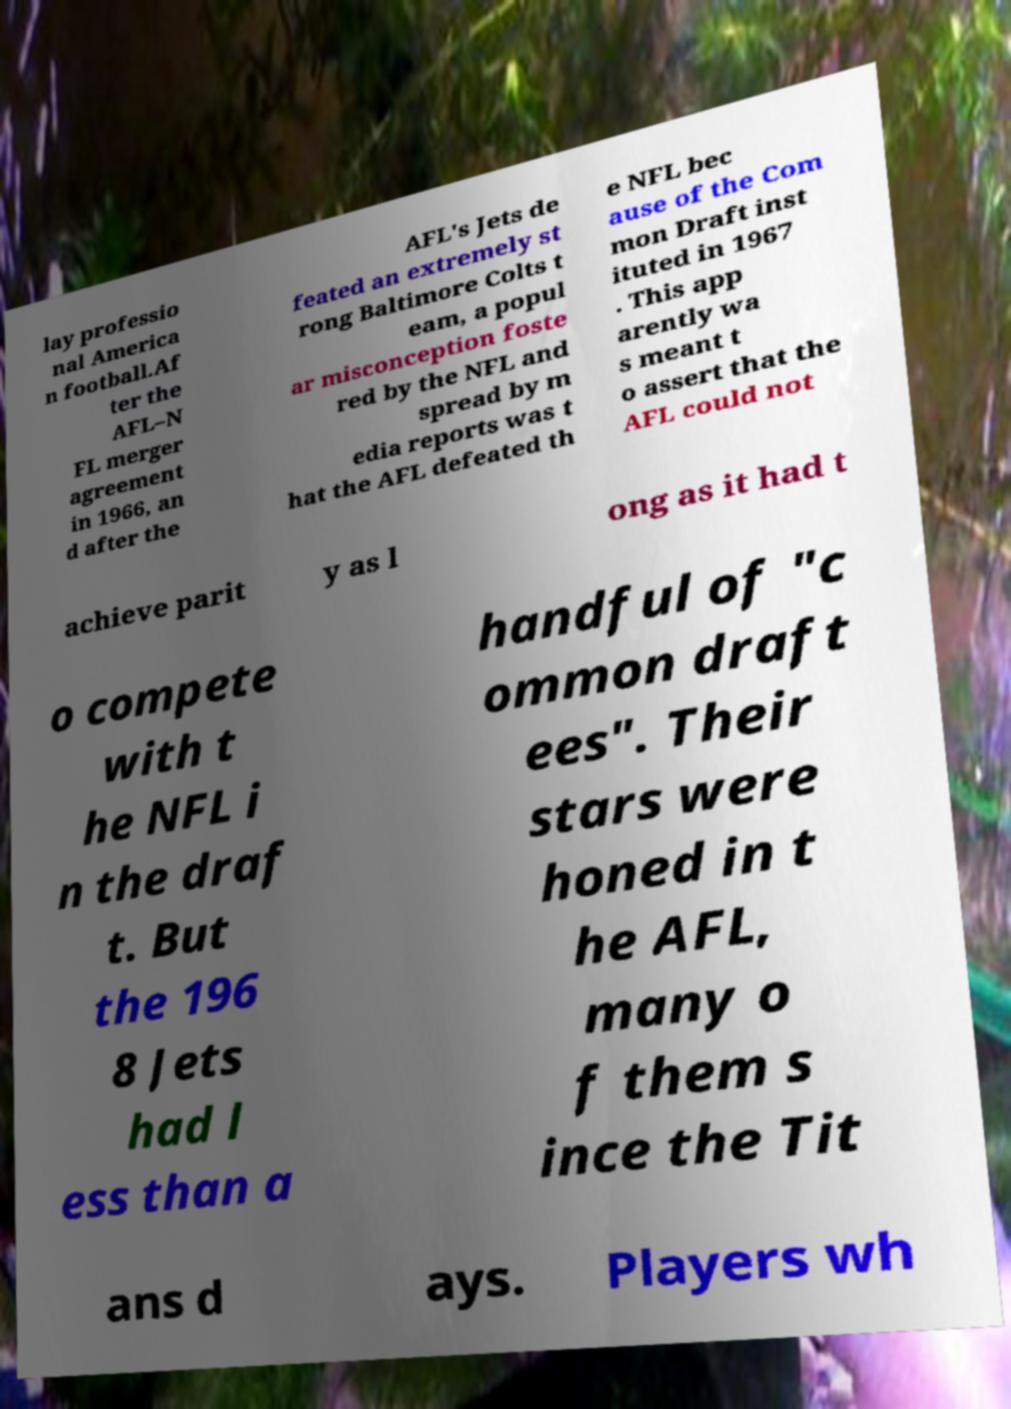I need the written content from this picture converted into text. Can you do that? lay professio nal America n football.Af ter the AFL–N FL merger agreement in 1966, an d after the AFL's Jets de feated an extremely st rong Baltimore Colts t eam, a popul ar misconception foste red by the NFL and spread by m edia reports was t hat the AFL defeated th e NFL bec ause of the Com mon Draft inst ituted in 1967 . This app arently wa s meant t o assert that the AFL could not achieve parit y as l ong as it had t o compete with t he NFL i n the draf t. But the 196 8 Jets had l ess than a handful of "c ommon draft ees". Their stars were honed in t he AFL, many o f them s ince the Tit ans d ays. Players wh 